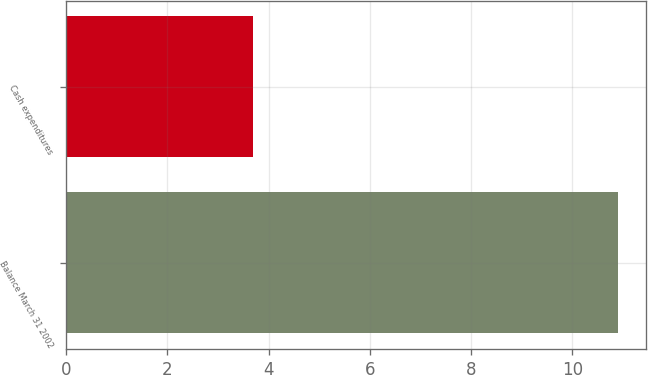<chart> <loc_0><loc_0><loc_500><loc_500><bar_chart><fcel>Balance March 31 2002<fcel>Cash expenditures<nl><fcel>10.9<fcel>3.7<nl></chart> 